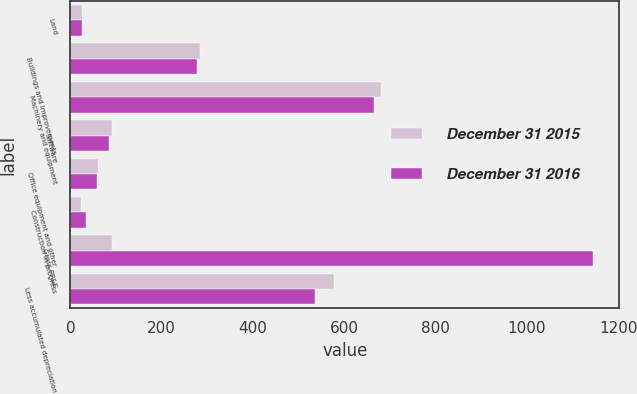<chart> <loc_0><loc_0><loc_500><loc_500><stacked_bar_chart><ecel><fcel>Land<fcel>Buildings and improvements<fcel>Machinery and equipment<fcel>Software<fcel>Office equipment and other<fcel>Construction in progress<fcel>Gross PP&E<fcel>Less accumulated depreciation<nl><fcel>December 31 2015<fcel>25.1<fcel>284.7<fcel>680.1<fcel>90.4<fcel>60.8<fcel>24.2<fcel>90.4<fcel>576.7<nl><fcel>December 31 2016<fcel>25.2<fcel>277.3<fcel>665.2<fcel>84.9<fcel>59.2<fcel>33.2<fcel>1145<fcel>535.4<nl></chart> 